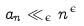Convert formula to latex. <formula><loc_0><loc_0><loc_500><loc_500>a _ { n } \ll _ { \epsilon } n ^ { \epsilon }</formula> 